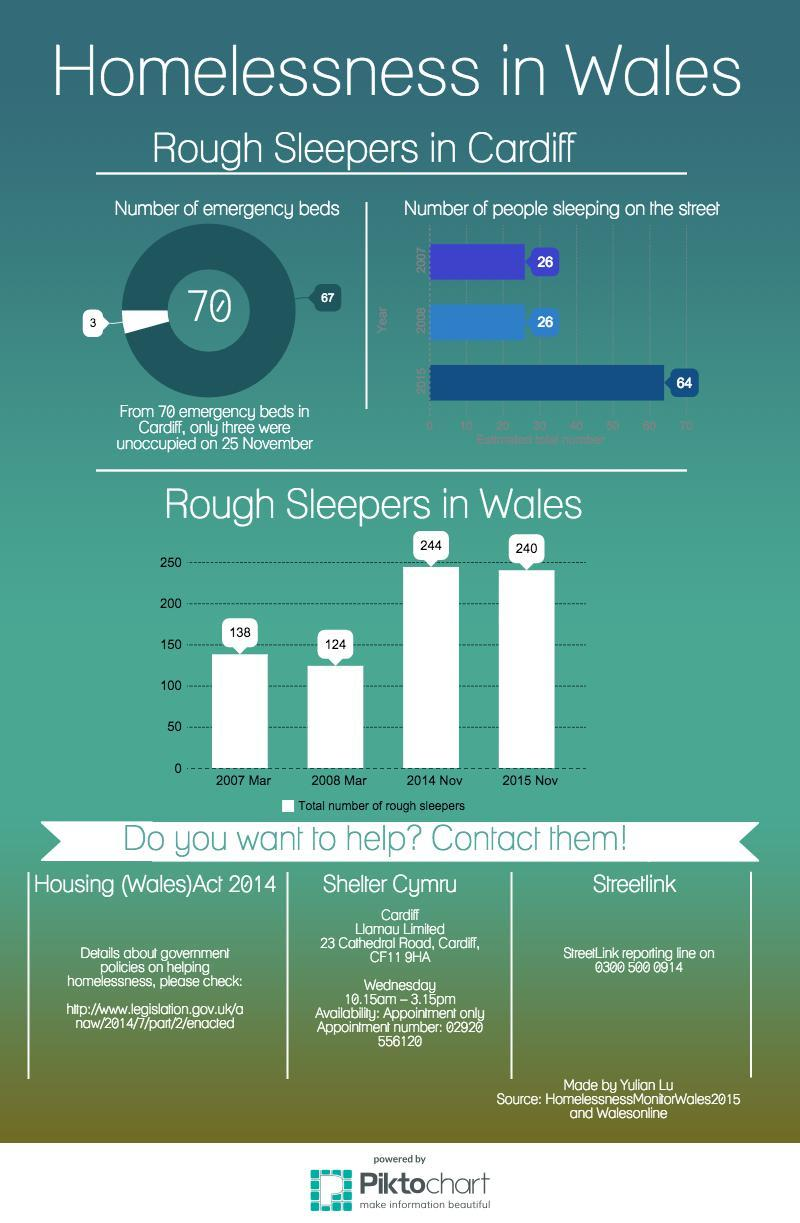Identify some key points in this picture. From March 2008 to November 2014, there was a significant increase in the number of rough sleepers in Wales. Specifically, there was a 100% increase in the number of rough sleepers during this time period. The number of rough sleepers in Wales decreased by 14 individuals from March 2007 to March 2008. From March 2007 to November 2015, there was a significant increase in the number of rough sleepers in Wales, with a total increase of 102 people. From November 2014 to November 2015, there was a significant reduction in the number of rough sleepers in Wales, as evidenced by the data provided. 